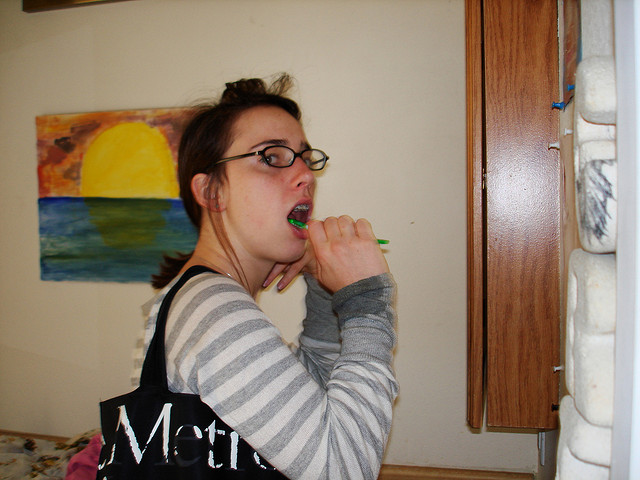Identify and read out the text in this image. Meti 